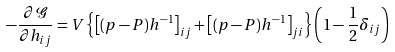Convert formula to latex. <formula><loc_0><loc_0><loc_500><loc_500>- \frac { \partial \mathcal { G } } { \partial h _ { i j } } = V \left \{ \left [ ( p - P ) h ^ { - 1 } \right ] _ { i j } + \left [ ( p - P ) h ^ { - 1 } \right ] _ { j i } \right \} \left ( 1 - \frac { 1 } { 2 } \delta _ { i j } \right )</formula> 